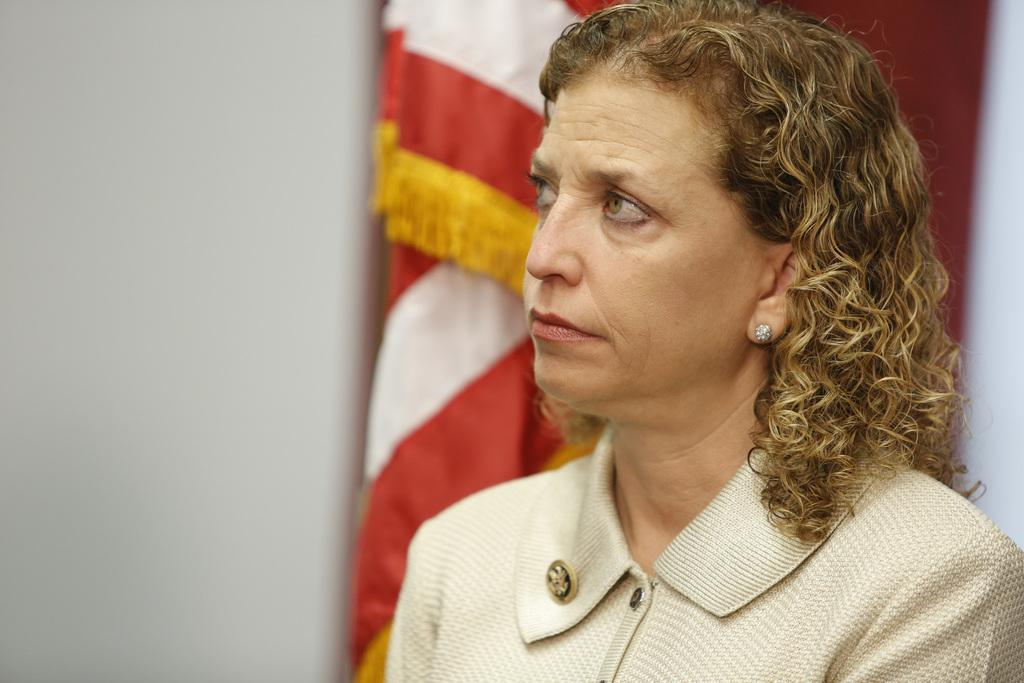Who is present in the image? There is a woman in the image. What can be seen in the background of the image? There is a flag and a wall in the background of the image. How is the background of the image depicted? The background is blurred. How many sheep are paying attention to the babies in the image? There are no sheep or babies present in the image. 